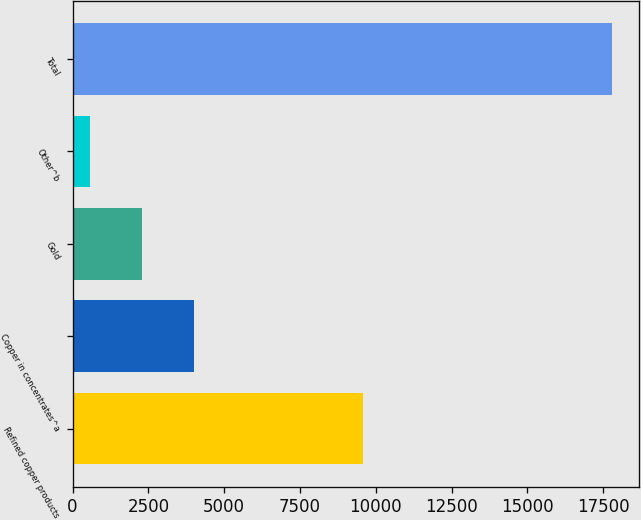<chart> <loc_0><loc_0><loc_500><loc_500><bar_chart><fcel>Refined copper products<fcel>Copper in concentrates^a<fcel>Gold<fcel>Other^b<fcel>Total<nl><fcel>9575<fcel>4017.6<fcel>2295.3<fcel>573<fcel>17796<nl></chart> 